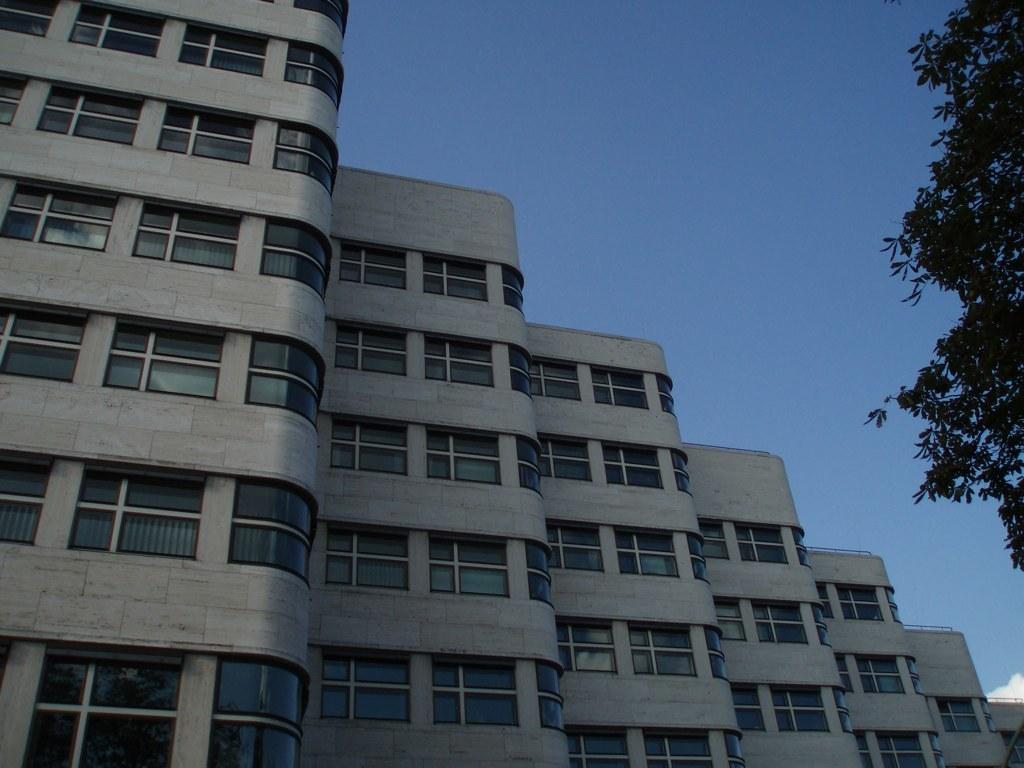What type of structures are visible in the image? There are buildings in the image. Where are the buildings located in relation to the image? The buildings are in front of the image. What type of vegetation can be seen on the right side of the image? There are leaves on the right side of the image. What is visible behind the buildings in the image? The sky is visible in the background of the image. Can you see any chess pieces on the buildings in the image? There are no chess pieces visible on the buildings in the image. What type of detail can be seen on the knife in the image? There is no knife present in the image. 